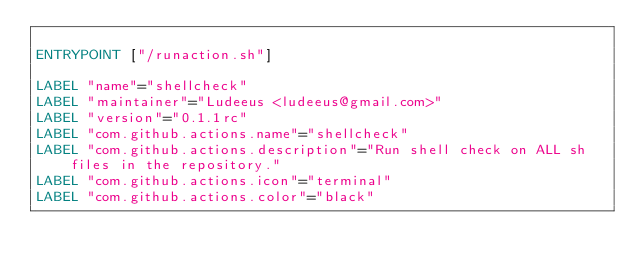Convert code to text. <code><loc_0><loc_0><loc_500><loc_500><_Dockerfile_>
ENTRYPOINT ["/runaction.sh"]

LABEL "name"="shellcheck"
LABEL "maintainer"="Ludeeus <ludeeus@gmail.com>"
LABEL "version"="0.1.1rc"
LABEL "com.github.actions.name"="shellcheck"
LABEL "com.github.actions.description"="Run shell check on ALL sh files in the repository."
LABEL "com.github.actions.icon"="terminal"
LABEL "com.github.actions.color"="black"
</code> 